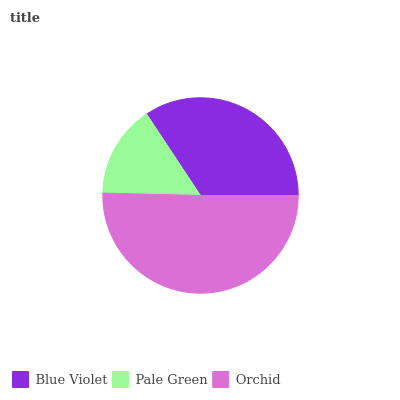Is Pale Green the minimum?
Answer yes or no. Yes. Is Orchid the maximum?
Answer yes or no. Yes. Is Orchid the minimum?
Answer yes or no. No. Is Pale Green the maximum?
Answer yes or no. No. Is Orchid greater than Pale Green?
Answer yes or no. Yes. Is Pale Green less than Orchid?
Answer yes or no. Yes. Is Pale Green greater than Orchid?
Answer yes or no. No. Is Orchid less than Pale Green?
Answer yes or no. No. Is Blue Violet the high median?
Answer yes or no. Yes. Is Blue Violet the low median?
Answer yes or no. Yes. Is Orchid the high median?
Answer yes or no. No. Is Pale Green the low median?
Answer yes or no. No. 